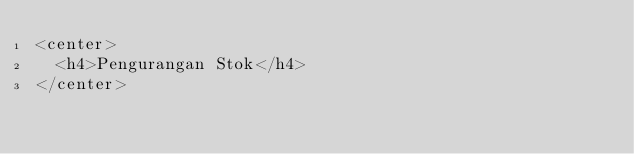Convert code to text. <code><loc_0><loc_0><loc_500><loc_500><_PHP_><center>
	<h4>Pengurangan Stok</h4>
</center></code> 